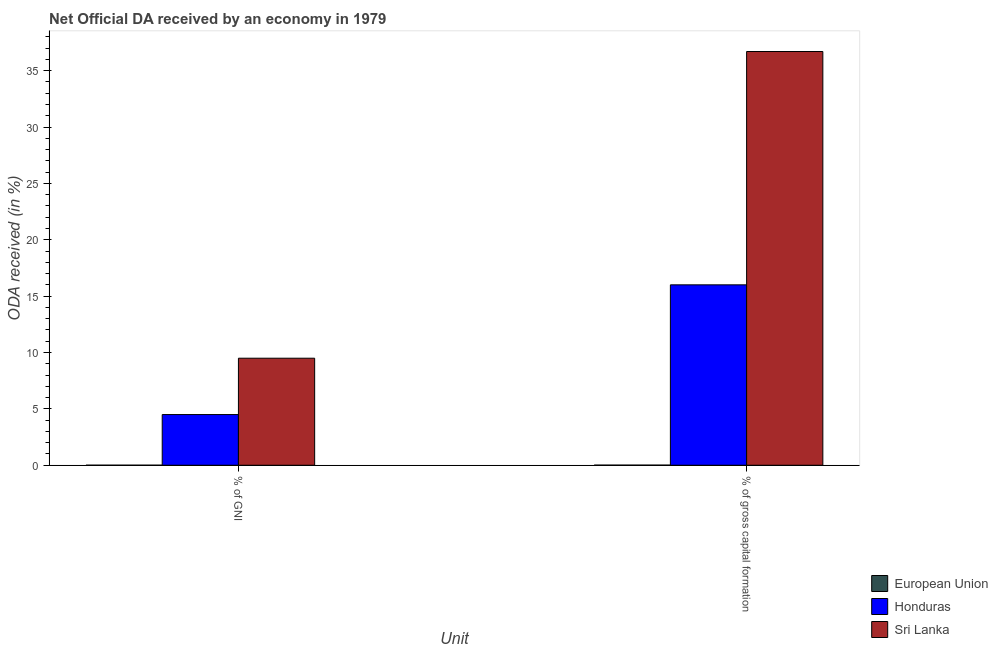How many different coloured bars are there?
Provide a succinct answer. 3. How many bars are there on the 2nd tick from the left?
Your answer should be very brief. 3. What is the label of the 1st group of bars from the left?
Offer a very short reply. % of GNI. What is the oda received as percentage of gross capital formation in European Union?
Your answer should be very brief. 0.01. Across all countries, what is the maximum oda received as percentage of gross capital formation?
Make the answer very short. 36.7. Across all countries, what is the minimum oda received as percentage of gross capital formation?
Ensure brevity in your answer.  0.01. In which country was the oda received as percentage of gni maximum?
Provide a short and direct response. Sri Lanka. In which country was the oda received as percentage of gross capital formation minimum?
Make the answer very short. European Union. What is the total oda received as percentage of gni in the graph?
Offer a terse response. 13.99. What is the difference between the oda received as percentage of gni in European Union and that in Honduras?
Your answer should be very brief. -4.49. What is the difference between the oda received as percentage of gni in Honduras and the oda received as percentage of gross capital formation in Sri Lanka?
Your answer should be very brief. -32.21. What is the average oda received as percentage of gross capital formation per country?
Make the answer very short. 17.57. What is the difference between the oda received as percentage of gni and oda received as percentage of gross capital formation in European Union?
Your answer should be compact. -0.01. What is the ratio of the oda received as percentage of gni in Sri Lanka to that in Honduras?
Give a very brief answer. 2.11. What does the 2nd bar from the left in % of gross capital formation represents?
Provide a short and direct response. Honduras. What does the 2nd bar from the right in % of GNI represents?
Make the answer very short. Honduras. Are all the bars in the graph horizontal?
Your answer should be very brief. No. How many countries are there in the graph?
Make the answer very short. 3. What is the difference between two consecutive major ticks on the Y-axis?
Your answer should be compact. 5. Are the values on the major ticks of Y-axis written in scientific E-notation?
Offer a very short reply. No. Does the graph contain any zero values?
Ensure brevity in your answer.  No. Does the graph contain grids?
Ensure brevity in your answer.  No. How many legend labels are there?
Your answer should be compact. 3. What is the title of the graph?
Offer a very short reply. Net Official DA received by an economy in 1979. Does "Northern Mariana Islands" appear as one of the legend labels in the graph?
Ensure brevity in your answer.  No. What is the label or title of the X-axis?
Provide a succinct answer. Unit. What is the label or title of the Y-axis?
Your answer should be compact. ODA received (in %). What is the ODA received (in %) of European Union in % of GNI?
Offer a terse response. 0. What is the ODA received (in %) in Honduras in % of GNI?
Your answer should be very brief. 4.5. What is the ODA received (in %) in Sri Lanka in % of GNI?
Make the answer very short. 9.49. What is the ODA received (in %) of European Union in % of gross capital formation?
Make the answer very short. 0.01. What is the ODA received (in %) of Honduras in % of gross capital formation?
Provide a short and direct response. 16. What is the ODA received (in %) of Sri Lanka in % of gross capital formation?
Ensure brevity in your answer.  36.7. Across all Unit, what is the maximum ODA received (in %) in European Union?
Offer a terse response. 0.01. Across all Unit, what is the maximum ODA received (in %) in Honduras?
Make the answer very short. 16. Across all Unit, what is the maximum ODA received (in %) of Sri Lanka?
Offer a terse response. 36.7. Across all Unit, what is the minimum ODA received (in %) in European Union?
Offer a very short reply. 0. Across all Unit, what is the minimum ODA received (in %) in Honduras?
Ensure brevity in your answer.  4.5. Across all Unit, what is the minimum ODA received (in %) of Sri Lanka?
Give a very brief answer. 9.49. What is the total ODA received (in %) of European Union in the graph?
Your answer should be very brief. 0.01. What is the total ODA received (in %) in Honduras in the graph?
Offer a terse response. 20.5. What is the total ODA received (in %) in Sri Lanka in the graph?
Ensure brevity in your answer.  46.2. What is the difference between the ODA received (in %) of European Union in % of GNI and that in % of gross capital formation?
Give a very brief answer. -0.01. What is the difference between the ODA received (in %) in Honduras in % of GNI and that in % of gross capital formation?
Your answer should be very brief. -11.51. What is the difference between the ODA received (in %) of Sri Lanka in % of GNI and that in % of gross capital formation?
Your answer should be very brief. -27.21. What is the difference between the ODA received (in %) of European Union in % of GNI and the ODA received (in %) of Honduras in % of gross capital formation?
Keep it short and to the point. -16. What is the difference between the ODA received (in %) of European Union in % of GNI and the ODA received (in %) of Sri Lanka in % of gross capital formation?
Provide a short and direct response. -36.7. What is the difference between the ODA received (in %) of Honduras in % of GNI and the ODA received (in %) of Sri Lanka in % of gross capital formation?
Your answer should be very brief. -32.21. What is the average ODA received (in %) of European Union per Unit?
Keep it short and to the point. 0.01. What is the average ODA received (in %) in Honduras per Unit?
Keep it short and to the point. 10.25. What is the average ODA received (in %) in Sri Lanka per Unit?
Offer a terse response. 23.1. What is the difference between the ODA received (in %) in European Union and ODA received (in %) in Honduras in % of GNI?
Your response must be concise. -4.49. What is the difference between the ODA received (in %) of European Union and ODA received (in %) of Sri Lanka in % of GNI?
Make the answer very short. -9.49. What is the difference between the ODA received (in %) in Honduras and ODA received (in %) in Sri Lanka in % of GNI?
Offer a terse response. -5. What is the difference between the ODA received (in %) of European Union and ODA received (in %) of Honduras in % of gross capital formation?
Offer a very short reply. -15.99. What is the difference between the ODA received (in %) in European Union and ODA received (in %) in Sri Lanka in % of gross capital formation?
Offer a terse response. -36.69. What is the difference between the ODA received (in %) of Honduras and ODA received (in %) of Sri Lanka in % of gross capital formation?
Give a very brief answer. -20.7. What is the ratio of the ODA received (in %) in European Union in % of GNI to that in % of gross capital formation?
Your response must be concise. 0.25. What is the ratio of the ODA received (in %) in Honduras in % of GNI to that in % of gross capital formation?
Keep it short and to the point. 0.28. What is the ratio of the ODA received (in %) of Sri Lanka in % of GNI to that in % of gross capital formation?
Offer a terse response. 0.26. What is the difference between the highest and the second highest ODA received (in %) of European Union?
Make the answer very short. 0.01. What is the difference between the highest and the second highest ODA received (in %) of Honduras?
Give a very brief answer. 11.51. What is the difference between the highest and the second highest ODA received (in %) in Sri Lanka?
Make the answer very short. 27.21. What is the difference between the highest and the lowest ODA received (in %) of European Union?
Your response must be concise. 0.01. What is the difference between the highest and the lowest ODA received (in %) in Honduras?
Ensure brevity in your answer.  11.51. What is the difference between the highest and the lowest ODA received (in %) of Sri Lanka?
Your answer should be very brief. 27.21. 